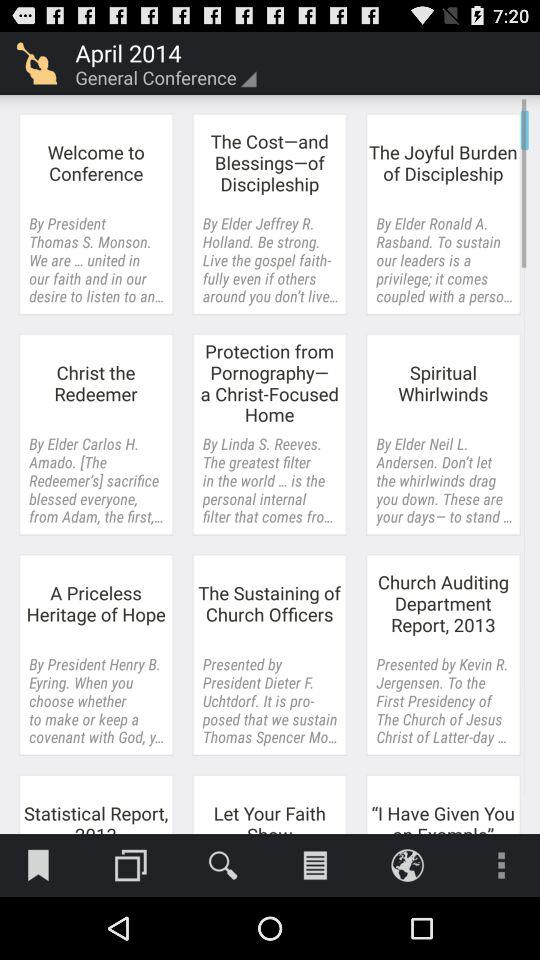What is the selected date for the general conference? The selected date is April 2014. 